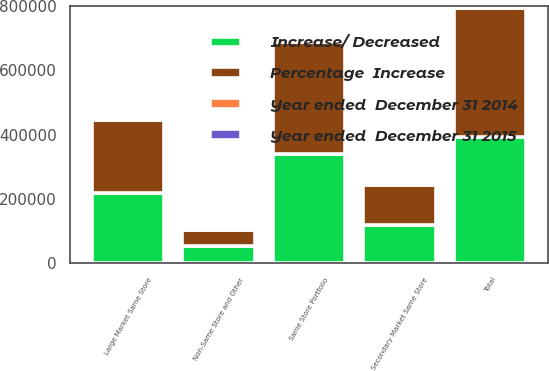<chart> <loc_0><loc_0><loc_500><loc_500><stacked_bar_chart><ecel><fcel>Large Market Same Store<fcel>Secondary Market Same Store<fcel>Same Store Portfolio<fcel>Non-Same Store and Other<fcel>Total<nl><fcel>Percentage  Increase<fcel>226611<fcel>123782<fcel>350393<fcel>50252<fcel>400645<nl><fcel>Increase/ Decreased<fcel>218784<fcel>119934<fcel>338718<fcel>54630<fcel>393348<nl><fcel>Year ended  December 31 2014<fcel>7827<fcel>3848<fcel>11675<fcel>4378<fcel>7297<nl><fcel>Year ended  December 31 2015<fcel>3.6<fcel>3.2<fcel>3.4<fcel>8<fcel>1.9<nl></chart> 